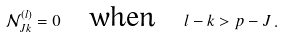<formula> <loc_0><loc_0><loc_500><loc_500>\mathcal { N } _ { J k } ^ { ( l ) } = 0 \quad \text {when} \quad l - k > p - J \, .</formula> 